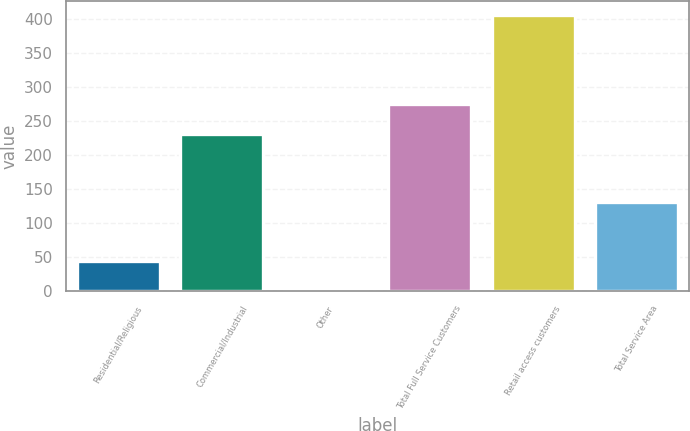Convert chart to OTSL. <chart><loc_0><loc_0><loc_500><loc_500><bar_chart><fcel>Residential/Religious<fcel>Commercial/Industrial<fcel>Other<fcel>Total Full Service Customers<fcel>Retail access customers<fcel>Total Service Area<nl><fcel>44.2<fcel>231<fcel>4<fcel>275<fcel>406<fcel>131<nl></chart> 